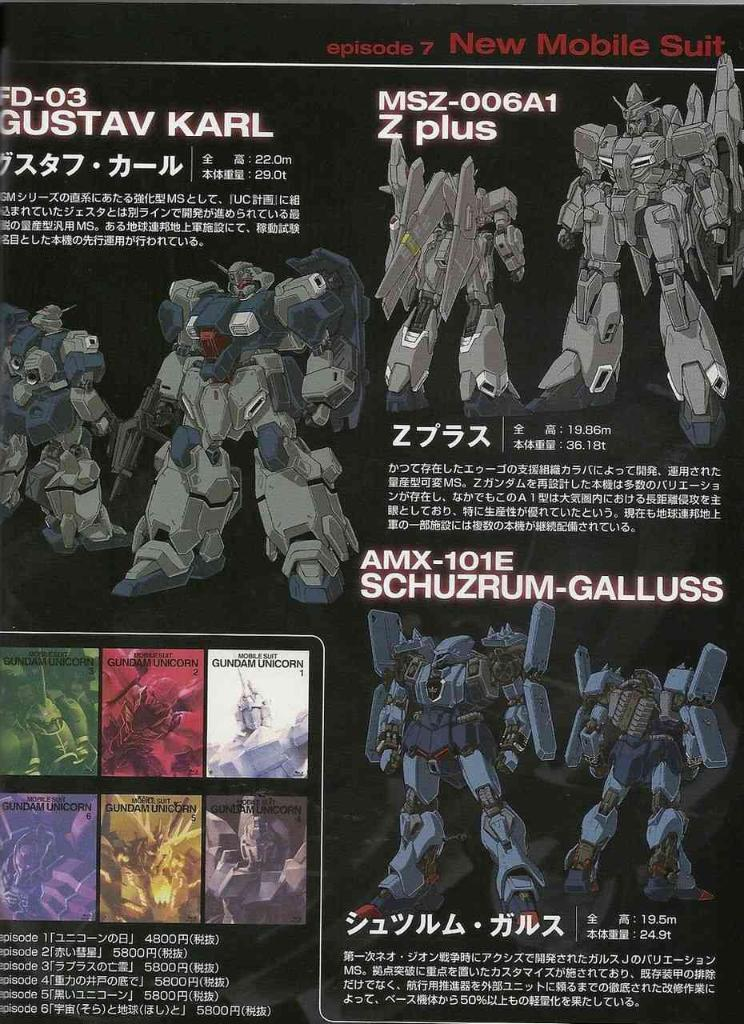Provide a one-sentence caption for the provided image. A page showing robots seen in episode 7 of New Mobile Suit. 